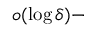<formula> <loc_0><loc_0><loc_500><loc_500>o ( \log \delta ) -</formula> 